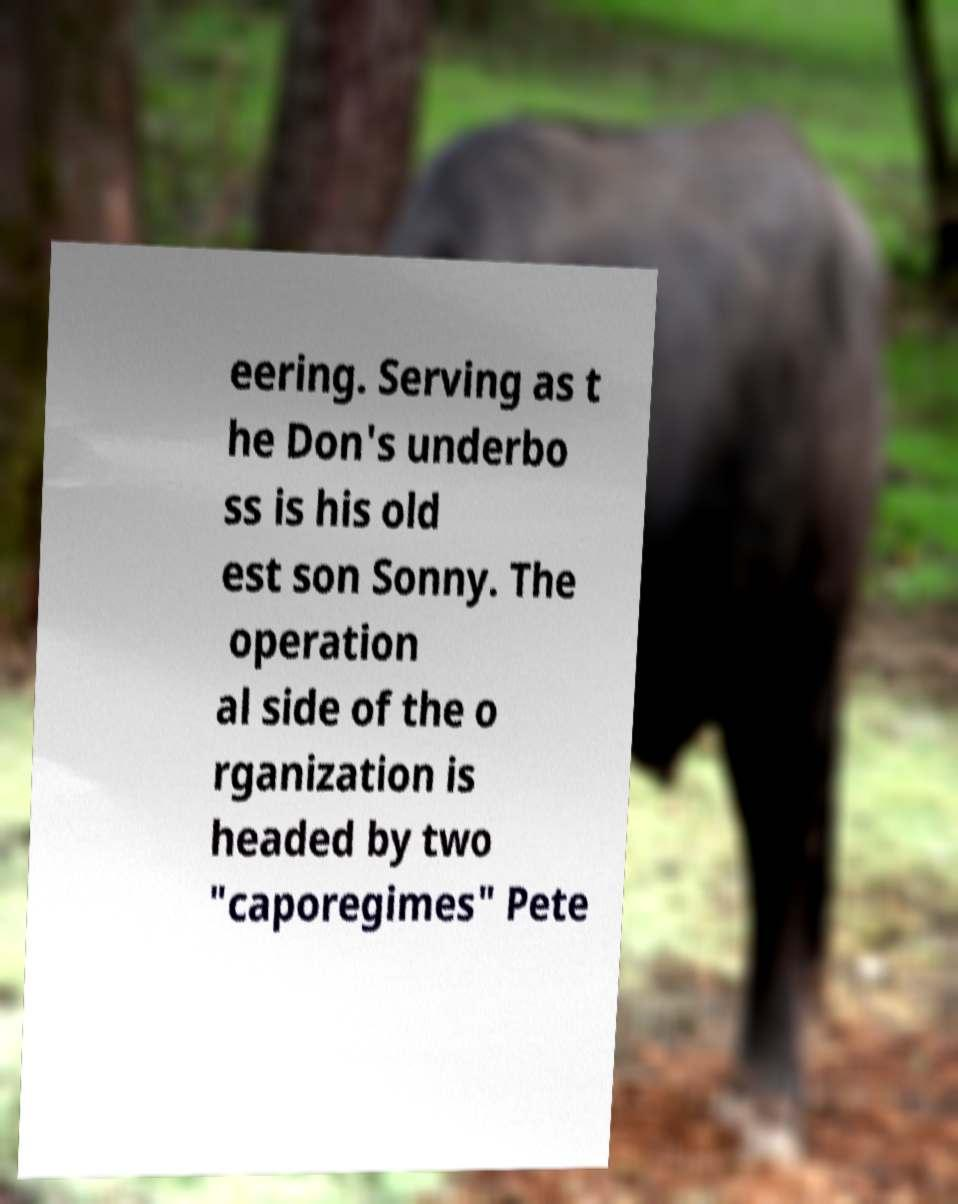Can you accurately transcribe the text from the provided image for me? eering. Serving as t he Don's underbo ss is his old est son Sonny. The operation al side of the o rganization is headed by two "caporegimes" Pete 